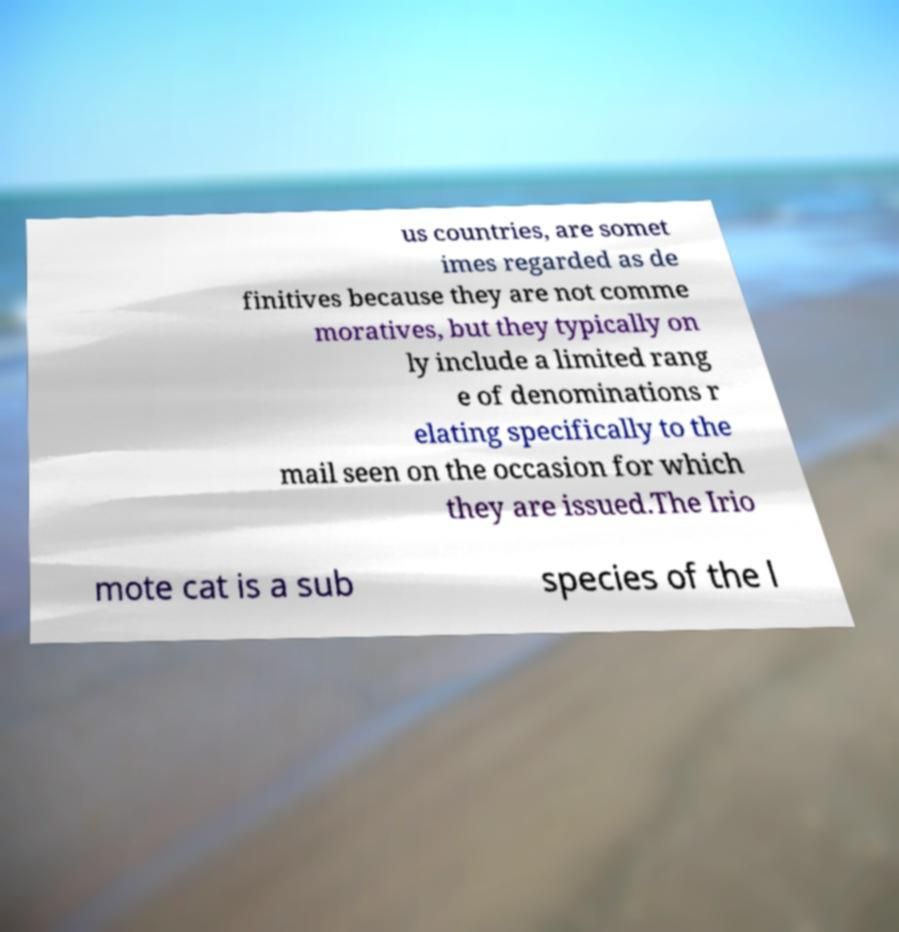Could you extract and type out the text from this image? us countries, are somet imes regarded as de finitives because they are not comme moratives, but they typically on ly include a limited rang e of denominations r elating specifically to the mail seen on the occasion for which they are issued.The Irio mote cat is a sub species of the l 